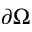<formula> <loc_0><loc_0><loc_500><loc_500>\partial \Omega</formula> 